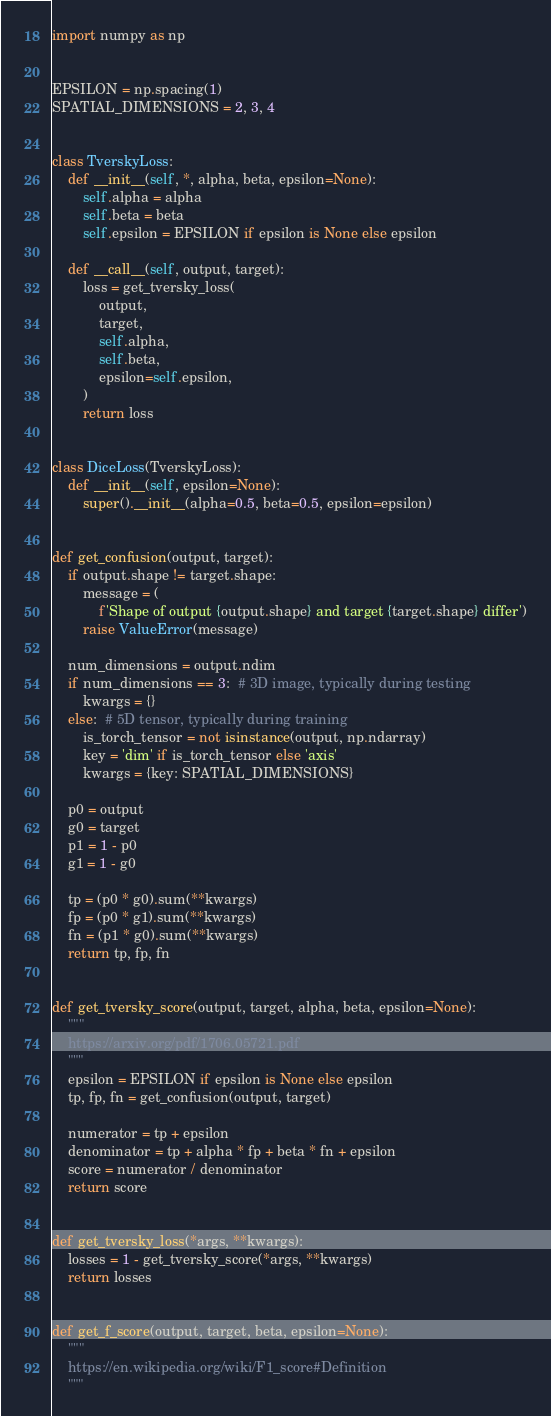<code> <loc_0><loc_0><loc_500><loc_500><_Python_>import numpy as np


EPSILON = np.spacing(1)
SPATIAL_DIMENSIONS = 2, 3, 4


class TverskyLoss:
    def __init__(self, *, alpha, beta, epsilon=None):
        self.alpha = alpha
        self.beta = beta
        self.epsilon = EPSILON if epsilon is None else epsilon

    def __call__(self, output, target):
        loss = get_tversky_loss(
            output,
            target,
            self.alpha,
            self.beta,
            epsilon=self.epsilon,
        )
        return loss


class DiceLoss(TverskyLoss):
    def __init__(self, epsilon=None):
        super().__init__(alpha=0.5, beta=0.5, epsilon=epsilon)


def get_confusion(output, target):
    if output.shape != target.shape:
        message = (
            f'Shape of output {output.shape} and target {target.shape} differ')
        raise ValueError(message)

    num_dimensions = output.ndim
    if num_dimensions == 3:  # 3D image, typically during testing
        kwargs = {}
    else:  # 5D tensor, typically during training
        is_torch_tensor = not isinstance(output, np.ndarray)
        key = 'dim' if is_torch_tensor else 'axis'
        kwargs = {key: SPATIAL_DIMENSIONS}

    p0 = output
    g0 = target
    p1 = 1 - p0
    g1 = 1 - g0

    tp = (p0 * g0).sum(**kwargs)
    fp = (p0 * g1).sum(**kwargs)
    fn = (p1 * g0).sum(**kwargs)
    return tp, fp, fn


def get_tversky_score(output, target, alpha, beta, epsilon=None):
    """
    https://arxiv.org/pdf/1706.05721.pdf
    """
    epsilon = EPSILON if epsilon is None else epsilon
    tp, fp, fn = get_confusion(output, target)

    numerator = tp + epsilon
    denominator = tp + alpha * fp + beta * fn + epsilon
    score = numerator / denominator
    return score


def get_tversky_loss(*args, **kwargs):
    losses = 1 - get_tversky_score(*args, **kwargs)
    return losses


def get_f_score(output, target, beta, epsilon=None):
    """
    https://en.wikipedia.org/wiki/F1_score#Definition
    """</code> 